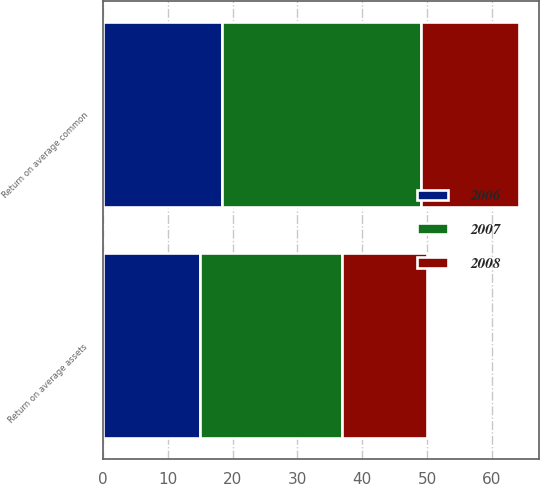Convert chart. <chart><loc_0><loc_0><loc_500><loc_500><stacked_bar_chart><ecel><fcel>Return on average assets<fcel>Return on average common<nl><fcel>2007<fcel>21.8<fcel>30.6<nl><fcel>2008<fcel>13.2<fcel>15.1<nl><fcel>2006<fcel>15<fcel>18.4<nl></chart> 